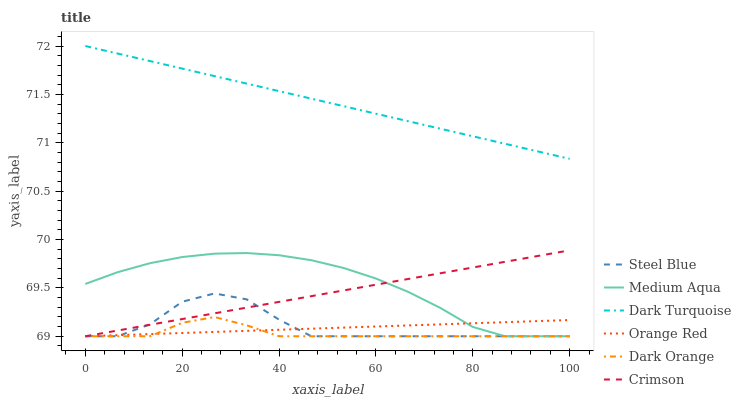Does Steel Blue have the minimum area under the curve?
Answer yes or no. No. Does Steel Blue have the maximum area under the curve?
Answer yes or no. No. Is Dark Turquoise the smoothest?
Answer yes or no. No. Is Dark Turquoise the roughest?
Answer yes or no. No. Does Dark Turquoise have the lowest value?
Answer yes or no. No. Does Steel Blue have the highest value?
Answer yes or no. No. Is Orange Red less than Dark Turquoise?
Answer yes or no. Yes. Is Dark Turquoise greater than Steel Blue?
Answer yes or no. Yes. Does Orange Red intersect Dark Turquoise?
Answer yes or no. No. 